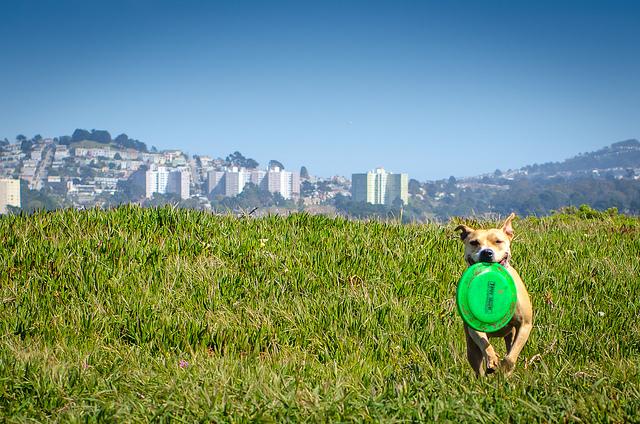What animal is this?
Keep it brief. Dog. What color is the frisbee?
Quick response, please. Green. Where are the buildings?
Give a very brief answer. Background. 